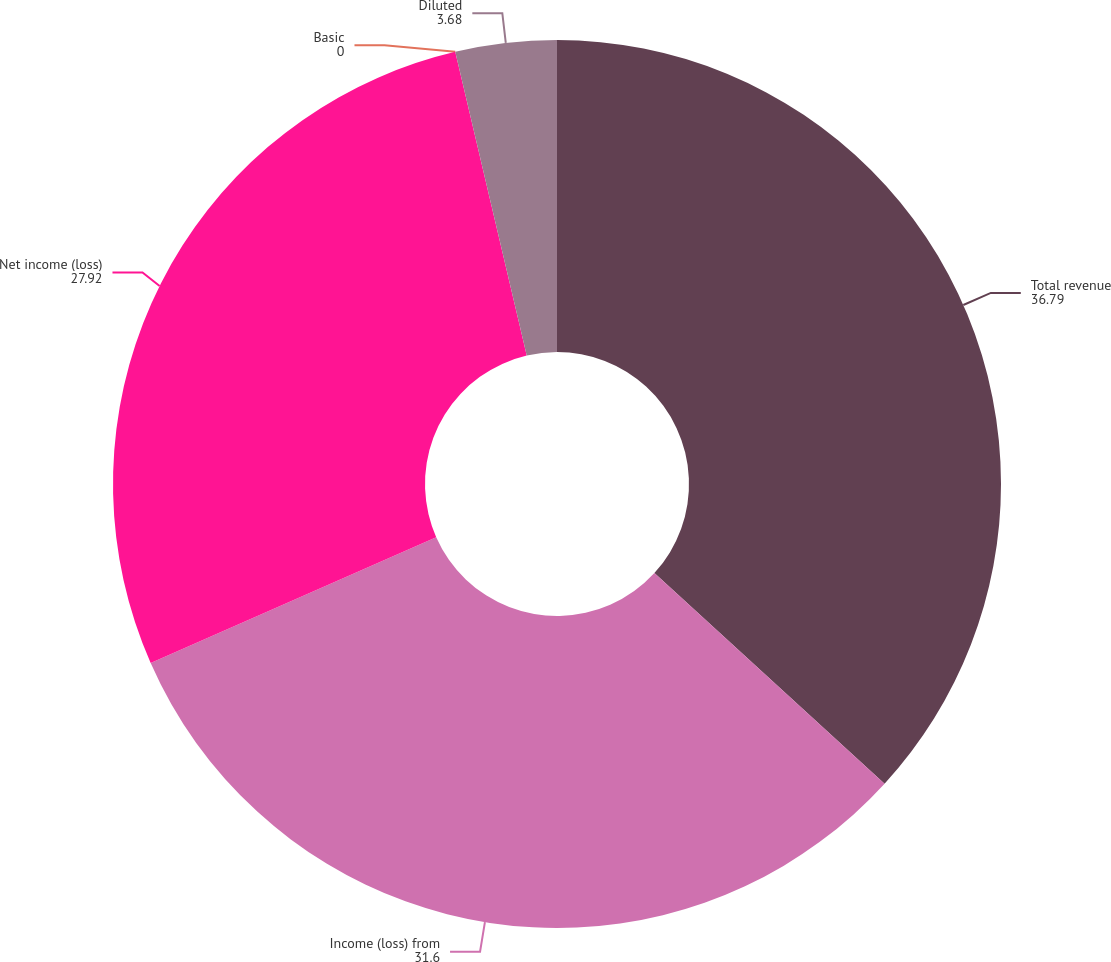<chart> <loc_0><loc_0><loc_500><loc_500><pie_chart><fcel>Total revenue<fcel>Income (loss) from<fcel>Net income (loss)<fcel>Basic<fcel>Diluted<nl><fcel>36.79%<fcel>31.6%<fcel>27.92%<fcel>0.0%<fcel>3.68%<nl></chart> 